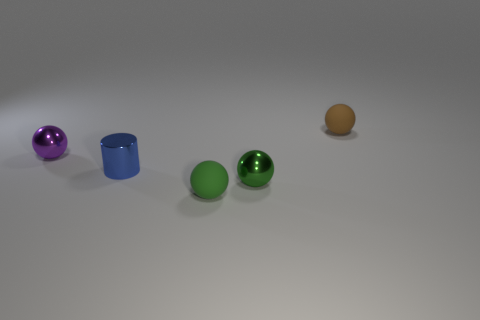Does the tiny matte object that is to the left of the brown matte sphere have the same shape as the purple thing that is behind the tiny green metallic thing?
Make the answer very short. Yes. How big is the blue thing?
Offer a very short reply. Small. What material is the tiny green object on the right side of the rubber thing in front of the rubber thing behind the cylinder?
Make the answer very short. Metal. What number of other objects are there of the same color as the cylinder?
Your answer should be compact. 0. What number of purple things are either spheres or small things?
Provide a short and direct response. 1. There is a tiny thing behind the purple object; what material is it?
Offer a very short reply. Rubber. Is the material of the thing to the left of the tiny blue metal cylinder the same as the tiny brown sphere?
Make the answer very short. No. What is the shape of the small purple thing?
Your answer should be very brief. Sphere. There is a tiny thing that is behind the object that is on the left side of the small shiny cylinder; how many tiny objects are behind it?
Keep it short and to the point. 0. How many other things are there of the same material as the brown object?
Provide a succinct answer. 1. 